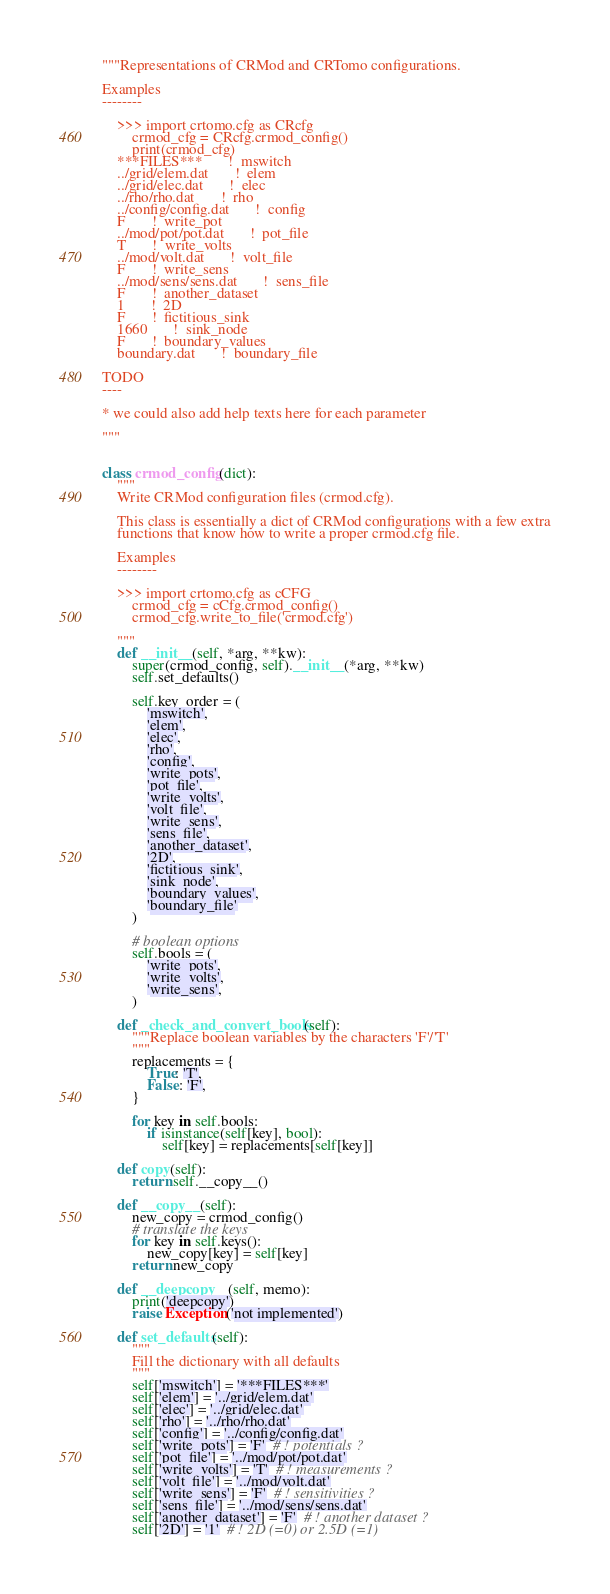Convert code to text. <code><loc_0><loc_0><loc_500><loc_500><_Python_>"""Representations of CRMod and CRTomo configurations.

Examples
--------

    >>> import crtomo.cfg as CRcfg
        crmod_cfg = CRcfg.crmod_config()
        print(crmod_cfg)
    ***FILES***       !  mswitch
    ../grid/elem.dat       !  elem
    ../grid/elec.dat       !  elec
    ../rho/rho.dat       !  rho
    ../config/config.dat       !  config
    F       !  write_pot
    ../mod/pot/pot.dat       !  pot_file
    T       !  write_volts
    ../mod/volt.dat       !  volt_file
    F       !  write_sens
    ../mod/sens/sens.dat       !  sens_file
    F       !  another_dataset
    1       !  2D
    F       !  fictitious_sink
    1660       !  sink_node
    F       !  boundary_values
    boundary.dat       !  boundary_file

TODO
----

* we could also add help texts here for each parameter

"""


class crmod_config(dict):
    """
    Write CRMod configuration files (crmod.cfg).

    This class is essentially a dict of CRMod configurations with a few extra
    functions that know how to write a proper crmod.cfg file.

    Examples
    --------

    >>> import crtomo.cfg as cCFG
        crmod_cfg = cCfg.crmod_config()
        crmod_cfg.write_to_file('crmod.cfg')

    """
    def __init__(self, *arg, **kw):
        super(crmod_config, self).__init__(*arg, **kw)
        self.set_defaults()

        self.key_order = (
            'mswitch',
            'elem',
            'elec',
            'rho',
            'config',
            'write_pots',
            'pot_file',
            'write_volts',
            'volt_file',
            'write_sens',
            'sens_file',
            'another_dataset',
            '2D',
            'fictitious_sink',
            'sink_node',
            'boundary_values',
            'boundary_file'
        )

        # boolean options
        self.bools = (
            'write_pots',
            'write_volts',
            'write_sens',
        )

    def _check_and_convert_bools(self):
        """Replace boolean variables by the characters 'F'/'T'
        """
        replacements = {
            True: 'T',
            False: 'F',
        }

        for key in self.bools:
            if isinstance(self[key], bool):
                self[key] = replacements[self[key]]

    def copy(self):
        return self.__copy__()

    def __copy__(self):
        new_copy = crmod_config()
        # translate the keys
        for key in self.keys():
            new_copy[key] = self[key]
        return new_copy

    def __deepcopy__(self, memo):
        print('deepcopy')
        raise Exception('not implemented')

    def set_defaults(self):
        """
        Fill the dictionary with all defaults
        """
        self['mswitch'] = '***FILES***'
        self['elem'] = '../grid/elem.dat'
        self['elec'] = '../grid/elec.dat'
        self['rho'] = '../rho/rho.dat'
        self['config'] = '../config/config.dat'
        self['write_pots'] = 'F'  # ! potentials ?
        self['pot_file'] = '../mod/pot/pot.dat'
        self['write_volts'] = 'T'  # ! measurements ?
        self['volt_file'] = '../mod/volt.dat'
        self['write_sens'] = 'F'  # ! sensitivities ?
        self['sens_file'] = '../mod/sens/sens.dat'
        self['another_dataset'] = 'F'  # ! another dataset ?
        self['2D'] = '1'  # ! 2D (=0) or 2.5D (=1)</code> 